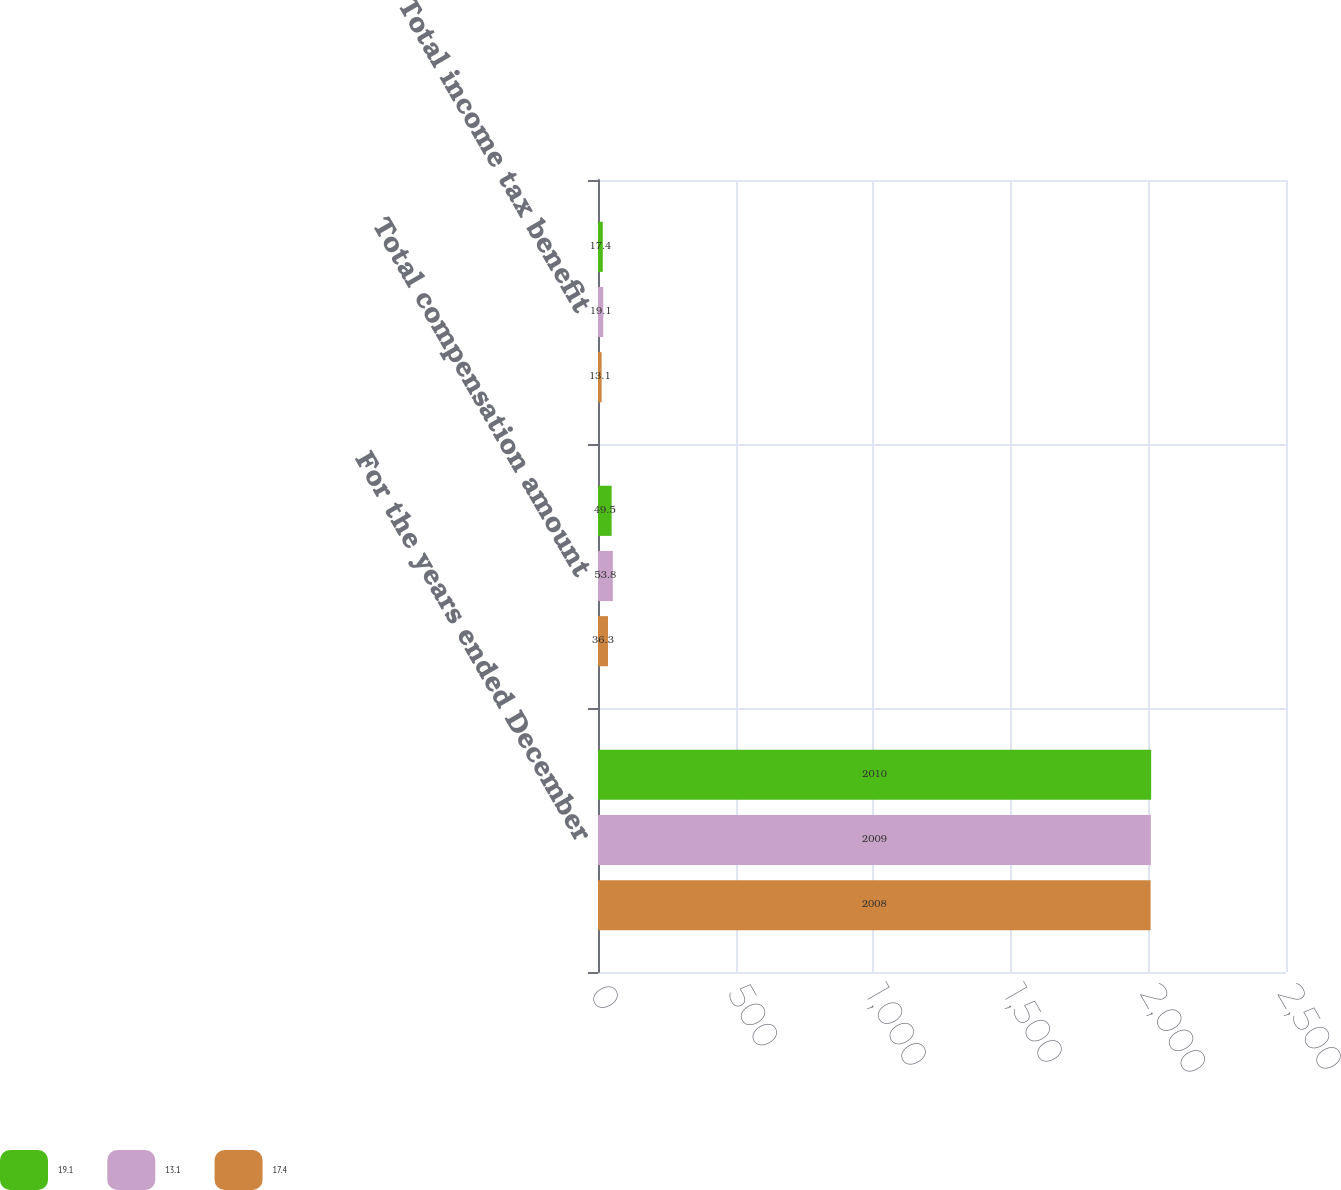<chart> <loc_0><loc_0><loc_500><loc_500><stacked_bar_chart><ecel><fcel>For the years ended December<fcel>Total compensation amount<fcel>Total income tax benefit<nl><fcel>19.1<fcel>2010<fcel>49.5<fcel>17.4<nl><fcel>13.1<fcel>2009<fcel>53.8<fcel>19.1<nl><fcel>17.4<fcel>2008<fcel>36.3<fcel>13.1<nl></chart> 